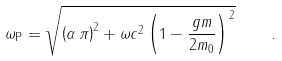Convert formula to latex. <formula><loc_0><loc_0><loc_500><loc_500>\omega _ { \mathrm P } = \sqrt { \left ( \alpha \, \pi \right ) ^ { 2 } + \omega c ^ { 2 } \left ( 1 - \frac { g m } { 2 m _ { 0 } } \right ) ^ { 2 } } \quad .</formula> 